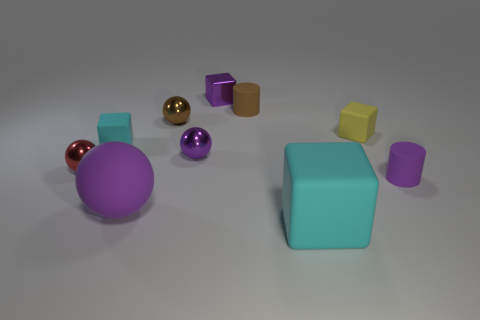Subtract all large rubber cubes. How many cubes are left? 3 Subtract all brown balls. How many balls are left? 3 Subtract all spheres. How many objects are left? 6 Subtract all gray spheres. Subtract all purple cubes. How many spheres are left? 4 Subtract all cyan cylinders. How many green spheres are left? 0 Subtract all cyan rubber spheres. Subtract all small cyan things. How many objects are left? 9 Add 8 small brown spheres. How many small brown spheres are left? 9 Add 7 tiny red metal things. How many tiny red metal things exist? 8 Subtract 1 purple cubes. How many objects are left? 9 Subtract 1 blocks. How many blocks are left? 3 